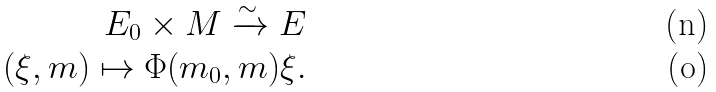<formula> <loc_0><loc_0><loc_500><loc_500>E _ { 0 } \times M \xrightarrow { \sim } E \\ ( \xi , m ) \mapsto \Phi ( m _ { 0 } , m ) \xi .</formula> 